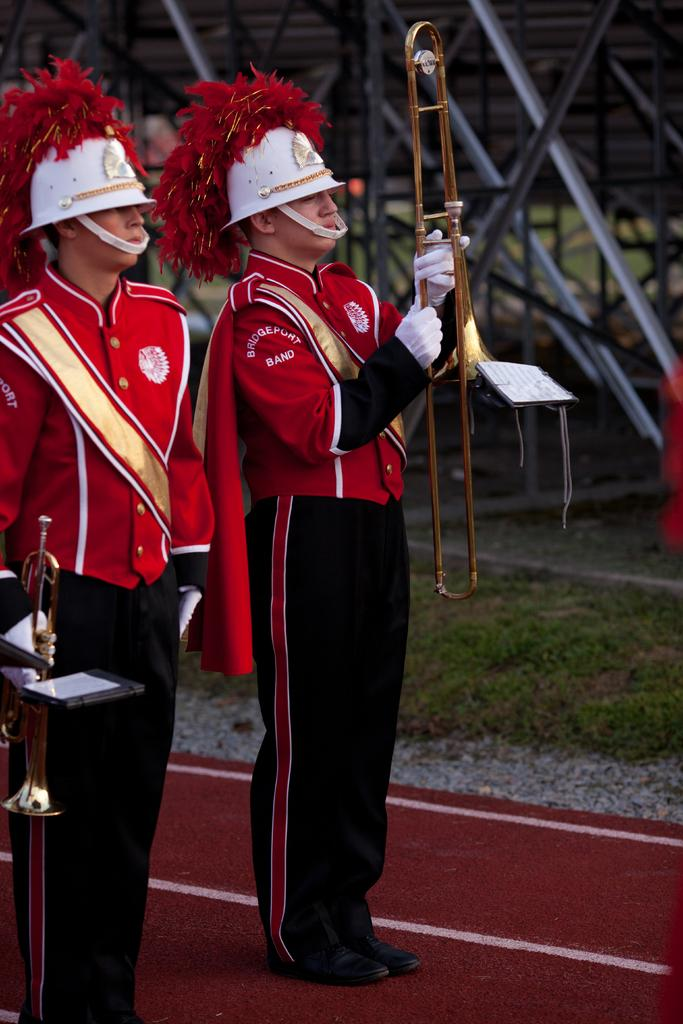<image>
Give a short and clear explanation of the subsequent image. A member of the Bridgeport Band holds his trumpet in front of him. 